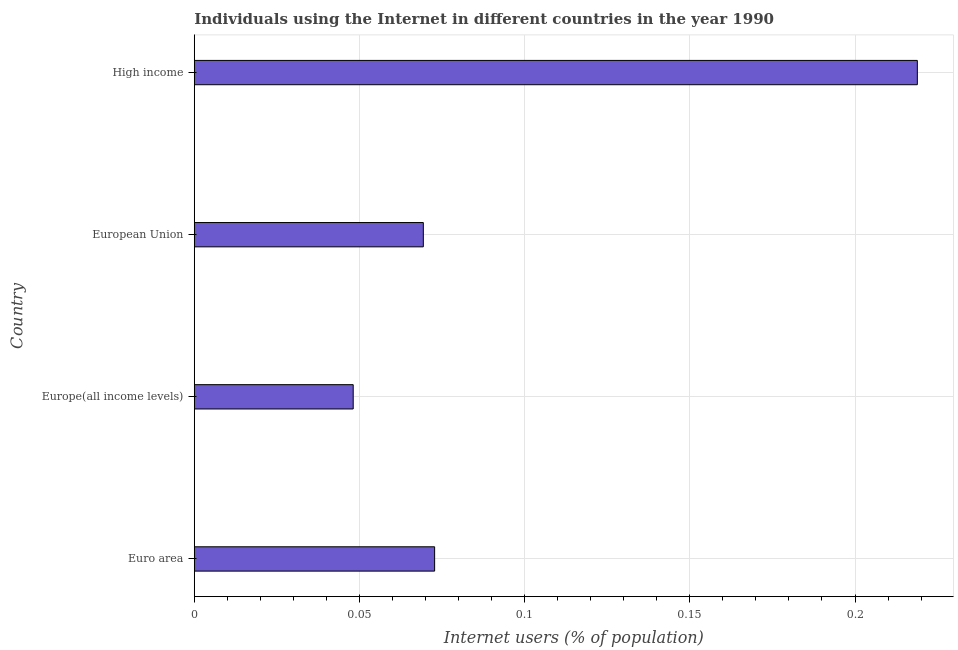Does the graph contain grids?
Provide a succinct answer. Yes. What is the title of the graph?
Your answer should be very brief. Individuals using the Internet in different countries in the year 1990. What is the label or title of the X-axis?
Offer a terse response. Internet users (% of population). What is the label or title of the Y-axis?
Your answer should be compact. Country. What is the number of internet users in European Union?
Provide a short and direct response. 0.07. Across all countries, what is the maximum number of internet users?
Make the answer very short. 0.22. Across all countries, what is the minimum number of internet users?
Provide a succinct answer. 0.05. In which country was the number of internet users minimum?
Your answer should be compact. Europe(all income levels). What is the sum of the number of internet users?
Keep it short and to the point. 0.41. What is the difference between the number of internet users in Euro area and Europe(all income levels)?
Provide a short and direct response. 0.03. What is the average number of internet users per country?
Give a very brief answer. 0.1. What is the median number of internet users?
Give a very brief answer. 0.07. In how many countries, is the number of internet users greater than 0.09 %?
Make the answer very short. 1. What is the ratio of the number of internet users in Euro area to that in High income?
Make the answer very short. 0.33. Is the number of internet users in Euro area less than that in Europe(all income levels)?
Provide a short and direct response. No. What is the difference between the highest and the second highest number of internet users?
Give a very brief answer. 0.15. What is the difference between the highest and the lowest number of internet users?
Provide a short and direct response. 0.17. In how many countries, is the number of internet users greater than the average number of internet users taken over all countries?
Your answer should be very brief. 1. How many countries are there in the graph?
Provide a short and direct response. 4. What is the difference between two consecutive major ticks on the X-axis?
Your answer should be compact. 0.05. Are the values on the major ticks of X-axis written in scientific E-notation?
Ensure brevity in your answer.  No. What is the Internet users (% of population) in Euro area?
Make the answer very short. 0.07. What is the Internet users (% of population) of Europe(all income levels)?
Offer a very short reply. 0.05. What is the Internet users (% of population) in European Union?
Keep it short and to the point. 0.07. What is the Internet users (% of population) in High income?
Make the answer very short. 0.22. What is the difference between the Internet users (% of population) in Euro area and Europe(all income levels)?
Offer a very short reply. 0.02. What is the difference between the Internet users (% of population) in Euro area and European Union?
Your answer should be compact. 0. What is the difference between the Internet users (% of population) in Euro area and High income?
Provide a succinct answer. -0.15. What is the difference between the Internet users (% of population) in Europe(all income levels) and European Union?
Provide a succinct answer. -0.02. What is the difference between the Internet users (% of population) in Europe(all income levels) and High income?
Provide a short and direct response. -0.17. What is the difference between the Internet users (% of population) in European Union and High income?
Offer a terse response. -0.15. What is the ratio of the Internet users (% of population) in Euro area to that in Europe(all income levels)?
Provide a succinct answer. 1.51. What is the ratio of the Internet users (% of population) in Euro area to that in European Union?
Your response must be concise. 1.05. What is the ratio of the Internet users (% of population) in Euro area to that in High income?
Offer a very short reply. 0.33. What is the ratio of the Internet users (% of population) in Europe(all income levels) to that in European Union?
Offer a very short reply. 0.69. What is the ratio of the Internet users (% of population) in Europe(all income levels) to that in High income?
Your answer should be compact. 0.22. What is the ratio of the Internet users (% of population) in European Union to that in High income?
Offer a terse response. 0.32. 